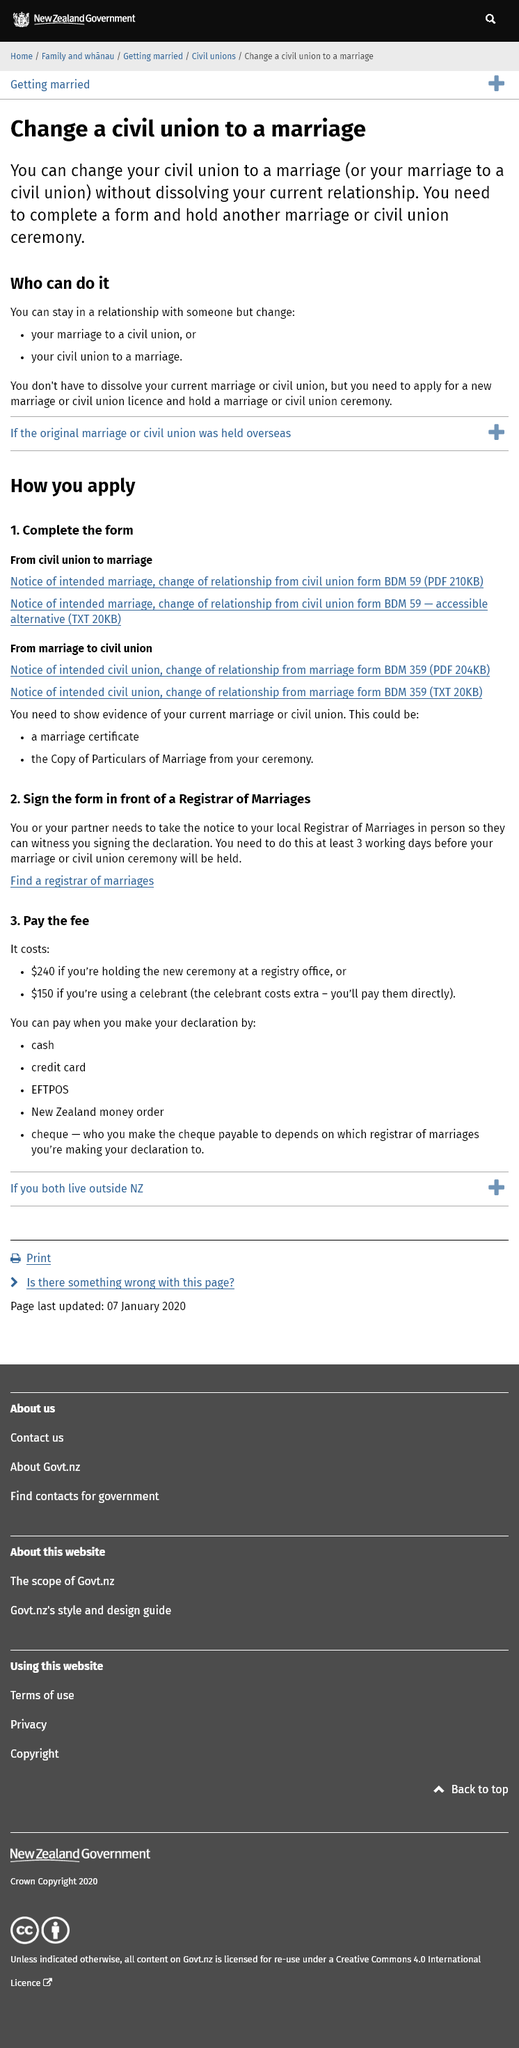Identify some key points in this picture. A marriage certificate is evidence of a current marriage or civil union. It is recommended that you visit the Registrar of Marriages at least 3 working days before the ceremony to ensure a smooth and stress-free event. When making a declaration, there are five ways in which payment can be made: cash, credit card, EFTPOS, New Zealand money order, and cheque. The payee on the cheque may vary depending on the registrar of marriages you are making the declaration to. To pay the fee, it costs $240 if the ceremony is held at a registry office. 